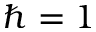<formula> <loc_0><loc_0><loc_500><loc_500>\hbar { = } 1</formula> 